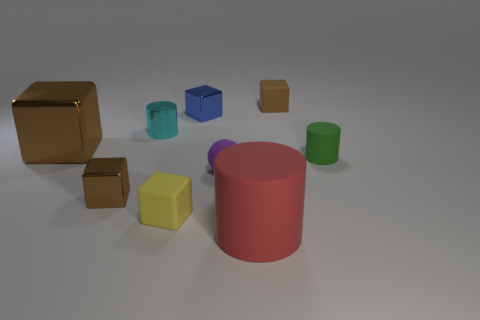Add 1 small red matte blocks. How many objects exist? 10 Subtract all tiny cylinders. How many cylinders are left? 1 Subtract all cyan cylinders. How many cylinders are left? 2 Subtract all cubes. How many objects are left? 4 Subtract all cyan blocks. Subtract all green balls. How many blocks are left? 5 Subtract all brown blocks. How many red cylinders are left? 1 Subtract all large brown cubes. Subtract all purple objects. How many objects are left? 7 Add 4 blue metallic things. How many blue metallic things are left? 5 Add 2 small yellow metallic cylinders. How many small yellow metallic cylinders exist? 2 Subtract 1 purple balls. How many objects are left? 8 